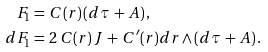<formula> <loc_0><loc_0><loc_500><loc_500>F _ { 1 } & = \, C ( r ) \, ( d \tau \, + \, A ) \, , \\ d F _ { 1 } & = \, 2 \, C ( r ) \, J \, + \, C ^ { \prime } ( r ) d r \wedge ( d \tau \, + \, A ) \, .</formula> 